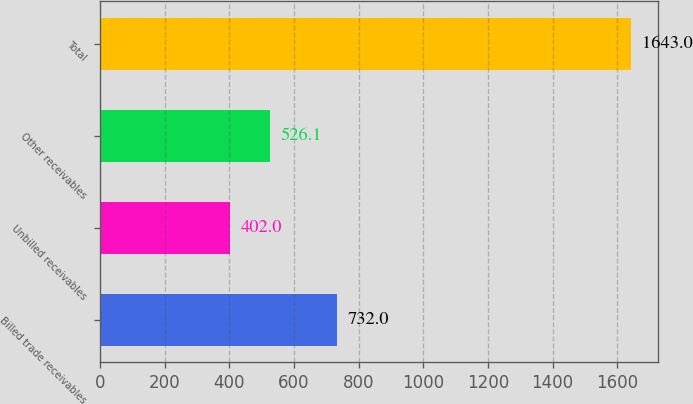<chart> <loc_0><loc_0><loc_500><loc_500><bar_chart><fcel>Billed trade receivables<fcel>Unbilled receivables<fcel>Other receivables<fcel>Total<nl><fcel>732<fcel>402<fcel>526.1<fcel>1643<nl></chart> 